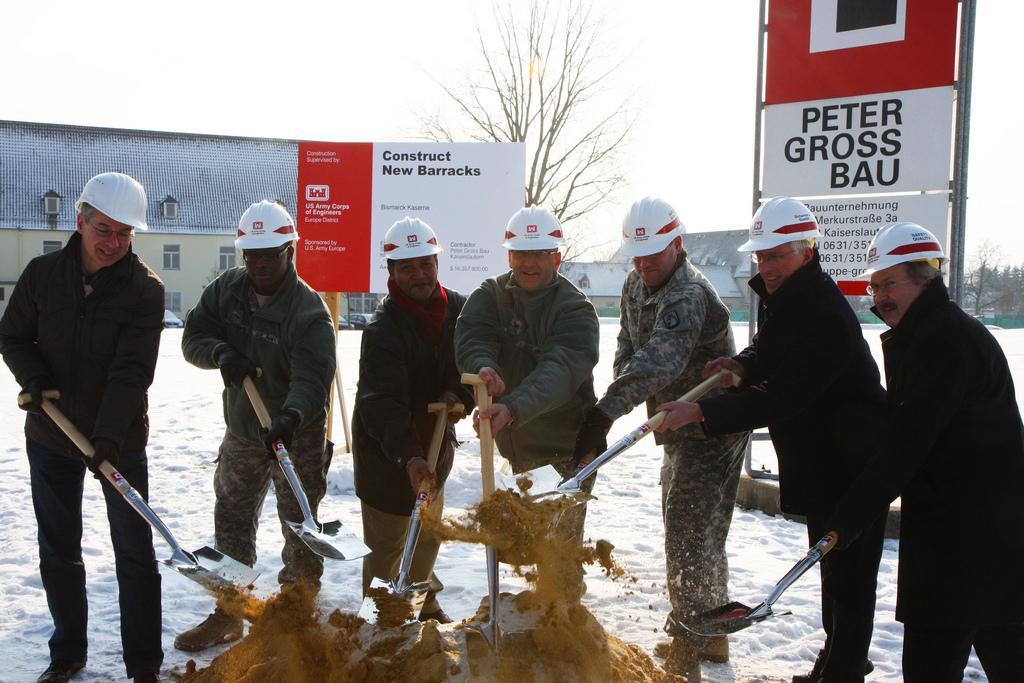How would you summarize this image in a sentence or two? In this picture I can see there are few people standing here and they are holding tools and there is soil here and they are wearing coats and helmets. There is snow on the floor and there are trees, buildings and there is a banner and another banner here. The sky is clear. 